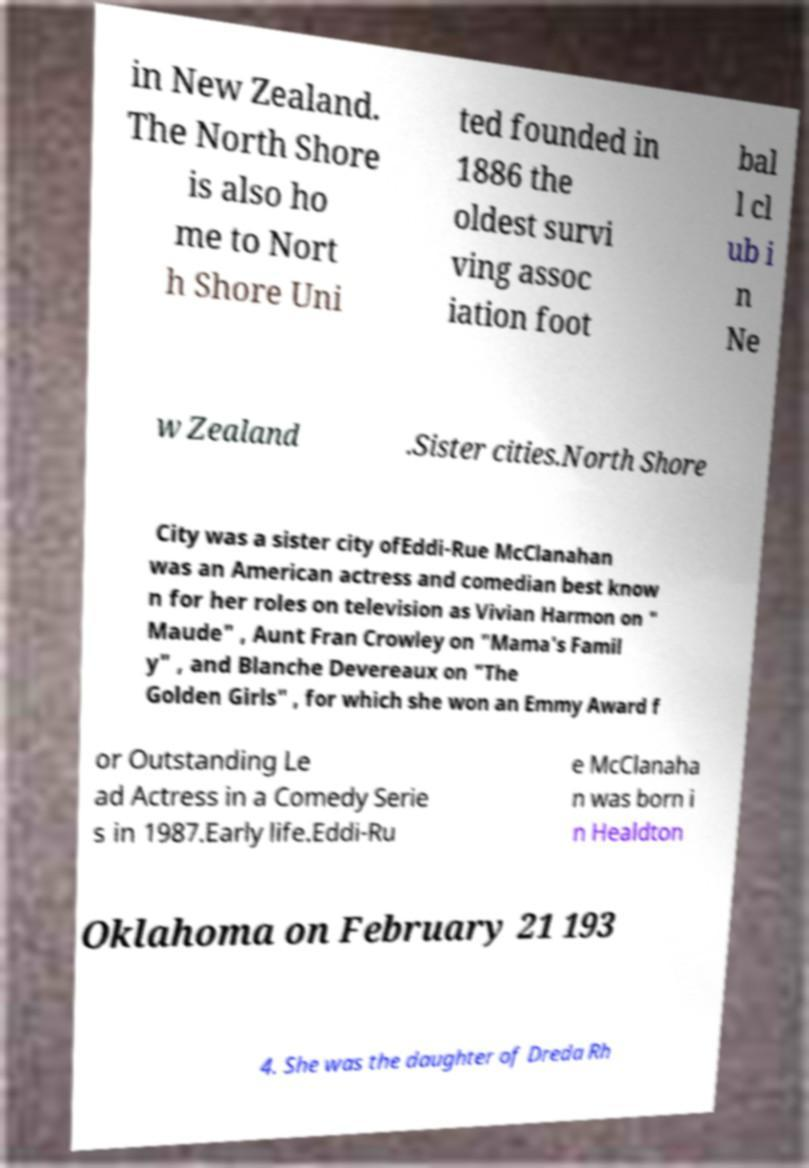Could you extract and type out the text from this image? in New Zealand. The North Shore is also ho me to Nort h Shore Uni ted founded in 1886 the oldest survi ving assoc iation foot bal l cl ub i n Ne w Zealand .Sister cities.North Shore City was a sister city ofEddi-Rue McClanahan was an American actress and comedian best know n for her roles on television as Vivian Harmon on " Maude" , Aunt Fran Crowley on "Mama's Famil y" , and Blanche Devereaux on "The Golden Girls" , for which she won an Emmy Award f or Outstanding Le ad Actress in a Comedy Serie s in 1987.Early life.Eddi-Ru e McClanaha n was born i n Healdton Oklahoma on February 21 193 4. She was the daughter of Dreda Rh 